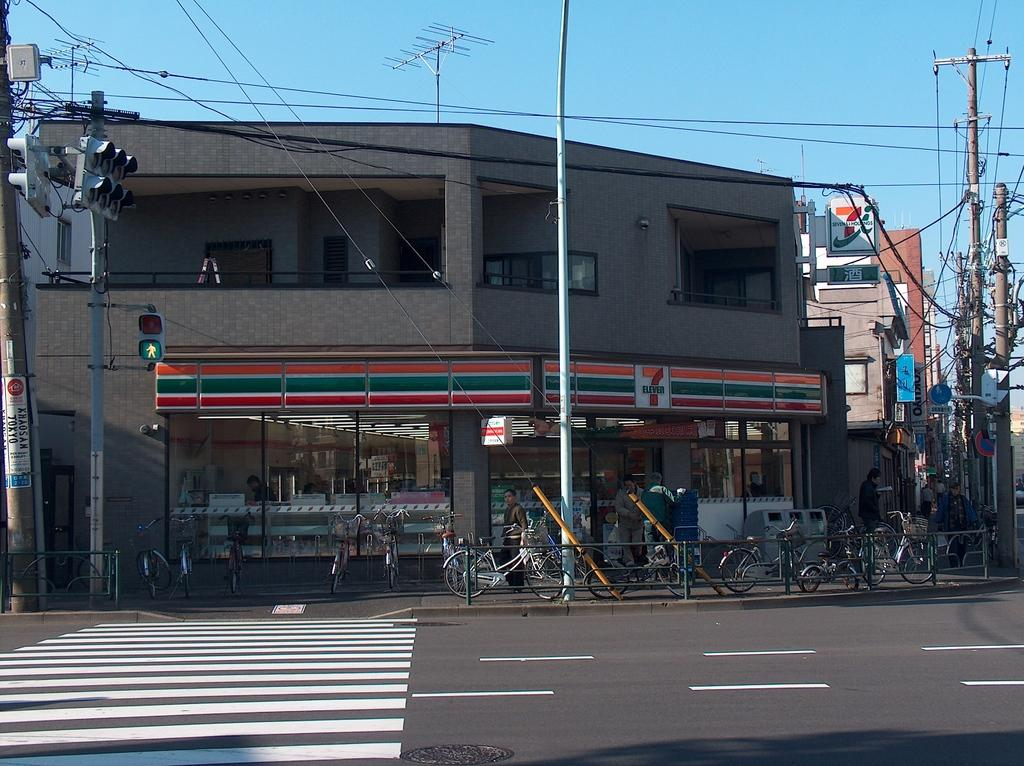<image>
Present a compact description of the photo's key features. Many bikes are sitting in front of a 7-Eleven. 